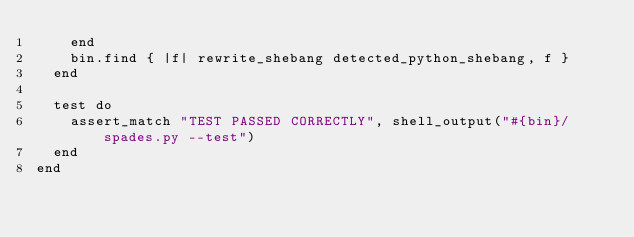Convert code to text. <code><loc_0><loc_0><loc_500><loc_500><_Ruby_>    end
    bin.find { |f| rewrite_shebang detected_python_shebang, f }
  end

  test do
    assert_match "TEST PASSED CORRECTLY", shell_output("#{bin}/spades.py --test")
  end
end
</code> 